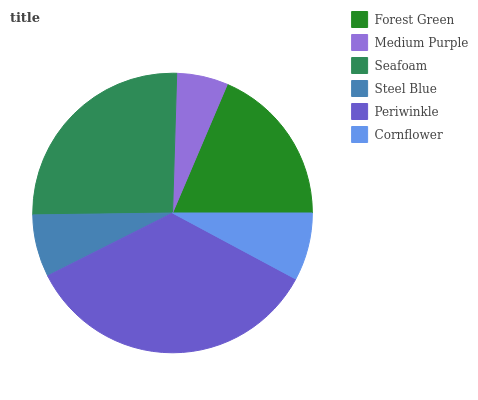Is Medium Purple the minimum?
Answer yes or no. Yes. Is Periwinkle the maximum?
Answer yes or no. Yes. Is Seafoam the minimum?
Answer yes or no. No. Is Seafoam the maximum?
Answer yes or no. No. Is Seafoam greater than Medium Purple?
Answer yes or no. Yes. Is Medium Purple less than Seafoam?
Answer yes or no. Yes. Is Medium Purple greater than Seafoam?
Answer yes or no. No. Is Seafoam less than Medium Purple?
Answer yes or no. No. Is Forest Green the high median?
Answer yes or no. Yes. Is Cornflower the low median?
Answer yes or no. Yes. Is Medium Purple the high median?
Answer yes or no. No. Is Seafoam the low median?
Answer yes or no. No. 